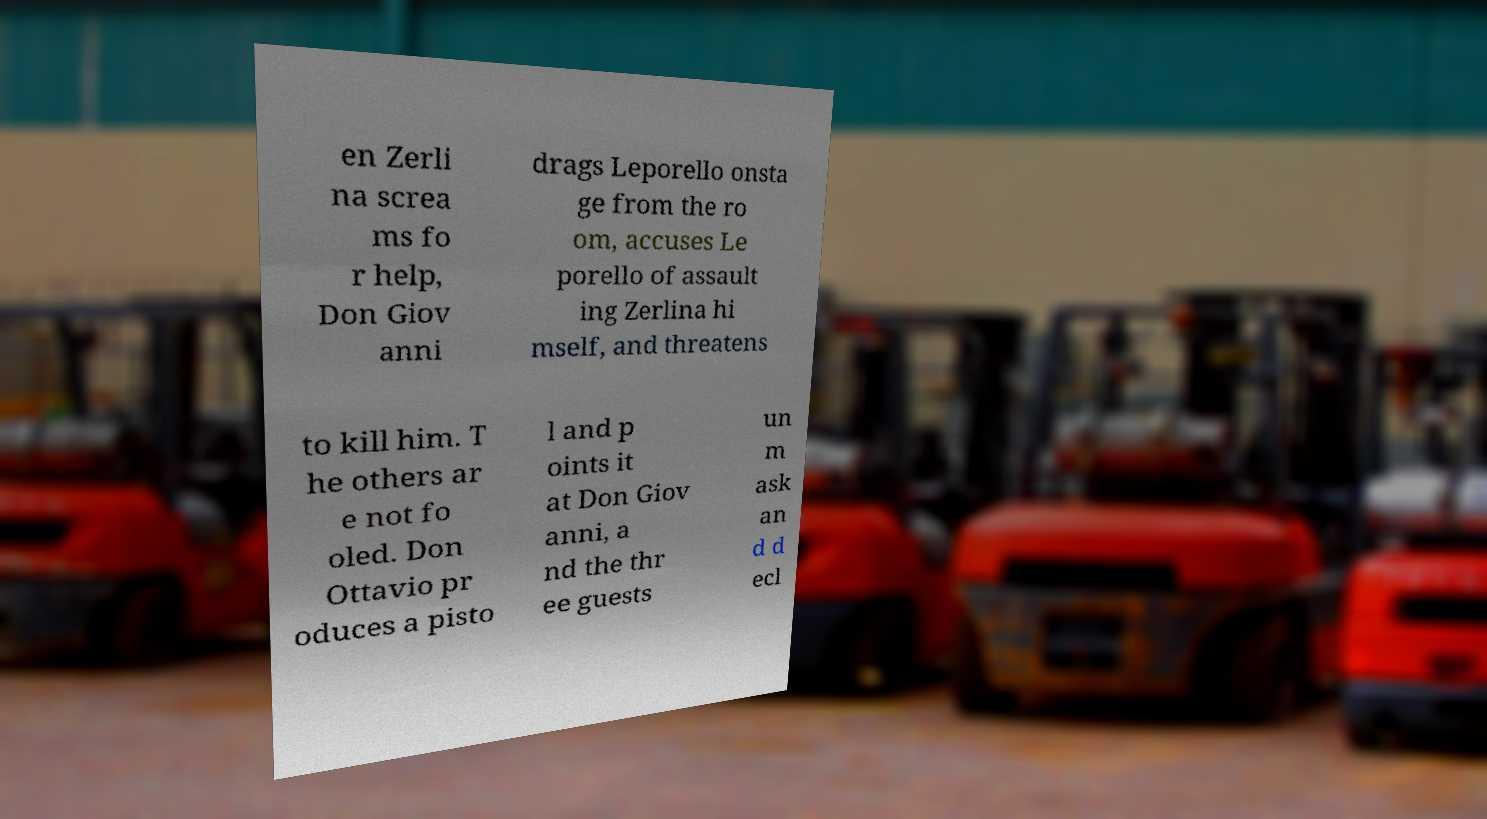For documentation purposes, I need the text within this image transcribed. Could you provide that? en Zerli na screa ms fo r help, Don Giov anni drags Leporello onsta ge from the ro om, accuses Le porello of assault ing Zerlina hi mself, and threatens to kill him. T he others ar e not fo oled. Don Ottavio pr oduces a pisto l and p oints it at Don Giov anni, a nd the thr ee guests un m ask an d d ecl 